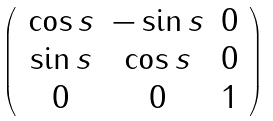<formula> <loc_0><loc_0><loc_500><loc_500>\left ( \, \begin{array} { c c c } \cos { s } & - \sin { s } & 0 \\ \sin { s } & \cos { s } & 0 \\ 0 & 0 & 1 \\ \end{array} \, \right )</formula> 